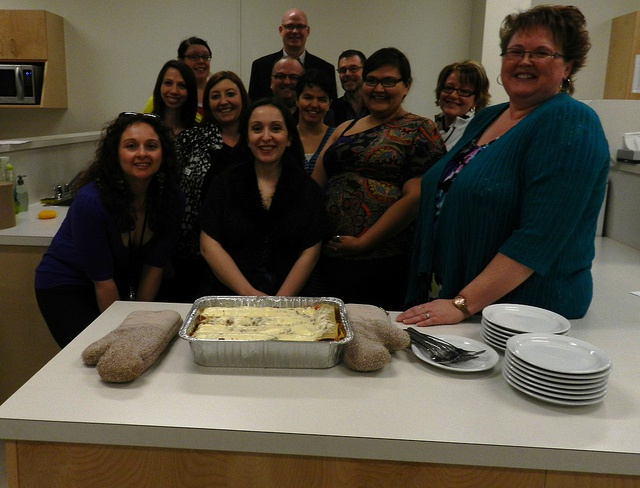Describe the objects in this image and their specific colors. I can see dining table in gray, darkgray, maroon, and tan tones, people in gray, black, maroon, and brown tones, people in gray, black, maroon, and brown tones, people in gray, black, and maroon tones, and people in gray, black, maroon, and brown tones in this image. 